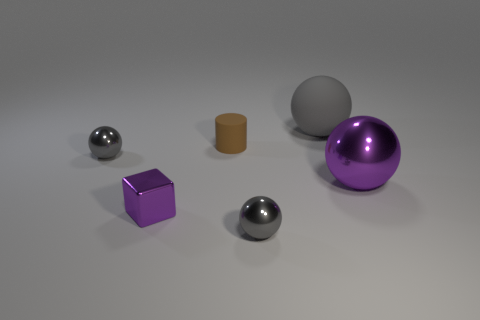Do the small sphere that is left of the small purple metal cube and the matte cylinder have the same color?
Offer a terse response. No. What number of other things are there of the same size as the gray matte thing?
Give a very brief answer. 1. Is the big purple ball made of the same material as the big gray ball?
Offer a very short reply. No. There is a tiny metal ball behind the purple metallic object on the right side of the large gray thing; what color is it?
Make the answer very short. Gray. The purple shiny thing that is the same shape as the gray rubber thing is what size?
Your response must be concise. Large. Do the cylinder and the big rubber thing have the same color?
Provide a succinct answer. No. What number of large purple shiny balls are to the left of the small gray metallic object on the left side of the gray shiny object that is to the right of the brown cylinder?
Your answer should be compact. 0. Are there more blue shiny spheres than tiny brown rubber cylinders?
Offer a very short reply. No. How many gray metallic objects are there?
Your answer should be very brief. 2. There is a big thing to the left of the purple object that is right of the small shiny sphere in front of the big metallic object; what is its shape?
Keep it short and to the point. Sphere. 